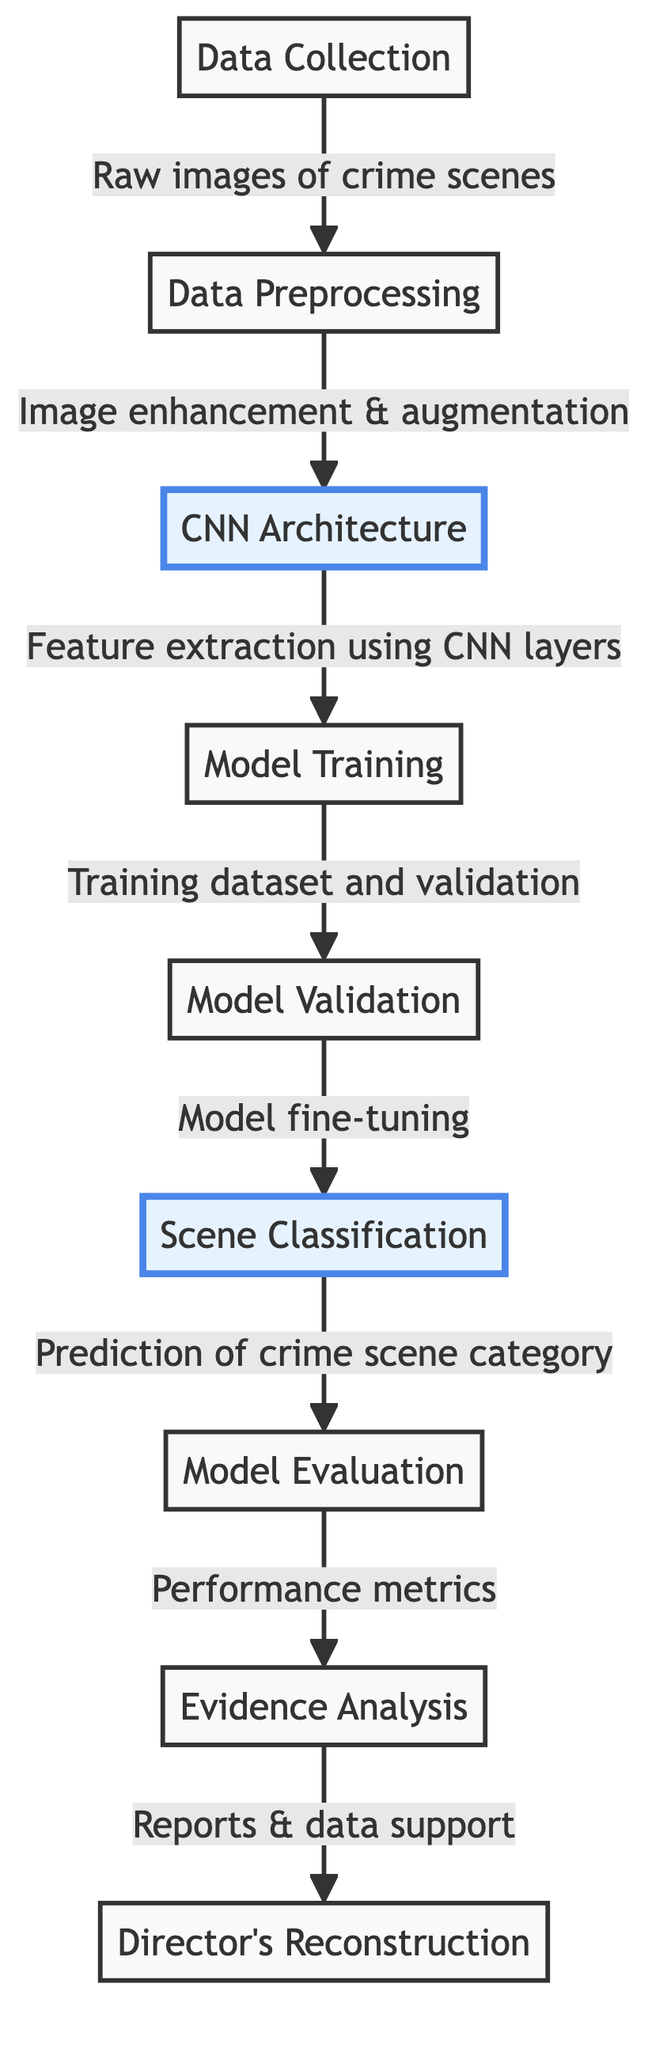What is the starting point of the flowchart? The starting point of the flowchart is the "Data Collection" node, which indicates the first step in the process of classifying crime scenes.
Answer: Data Collection How many nodes are in the diagram? By counting each unique process or stage identified in the diagram, we can find that there are a total of eight nodes present.
Answer: Eight Which node follows "Data Preprocessing"? According to the directional arrows in the diagram, the node immediately following "Data Preprocessing" is "CNN Architecture."
Answer: CNN Architecture What type of data is submitted to the "Model Training" node? The diagram indicates that the data submitted to the "Model Training" node consists of the "Training dataset and validation" as part of the training process.
Answer: Training dataset and validation What is the final output of the flowchart? The final output of the flowchart is connected to the "Director's Reconstruction," which represents the end of the process where evidence is used to support criminal reconstructions.
Answer: Director's Reconstruction Which node emphasizes feature extraction? The "CNN Architecture" node is highlighted in the diagram, indicating its significance in the flow of the classification process, specifically for feature extraction.
Answer: CNN Architecture What happens between "Model Validation" and "Scene Classification"? The diagram links "Model Validation" to "Classification," indicating that the model fine-tuning occurs between these two stages to improve accuracy.
Answer: Model fine-tuning Which two nodes are connected directly by a single edge? The nodes "Data Collection" and "Data Preprocessing" are directly connected by a single edge, showcasing a clear transition between the collection and preparation steps.
Answer: Data Collection and Data Preprocessing What aspect of performance is assessed in the "Model Evaluation" node? The diagram specifies that the "Model Evaluation" node focuses on "Performance metrics," which suggests an assessment of the model's effectiveness after training and validation.
Answer: Performance metrics 